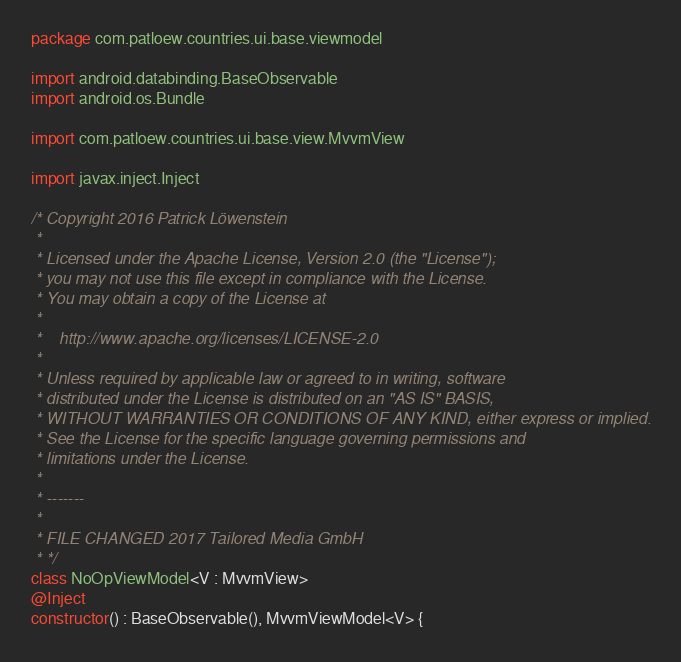Convert code to text. <code><loc_0><loc_0><loc_500><loc_500><_Kotlin_>package com.patloew.countries.ui.base.viewmodel

import android.databinding.BaseObservable
import android.os.Bundle

import com.patloew.countries.ui.base.view.MvvmView

import javax.inject.Inject

/* Copyright 2016 Patrick Löwenstein
 *
 * Licensed under the Apache License, Version 2.0 (the "License");
 * you may not use this file except in compliance with the License.
 * You may obtain a copy of the License at
 *
 *    http://www.apache.org/licenses/LICENSE-2.0
 *
 * Unless required by applicable law or agreed to in writing, software
 * distributed under the License is distributed on an "AS IS" BASIS,
 * WITHOUT WARRANTIES OR CONDITIONS OF ANY KIND, either express or implied.
 * See the License for the specific language governing permissions and
 * limitations under the License.
 *
 * -------
 *
 * FILE CHANGED 2017 Tailored Media GmbH
 * */
class NoOpViewModel<V : MvvmView>
@Inject
constructor() : BaseObservable(), MvvmViewModel<V> {
</code> 